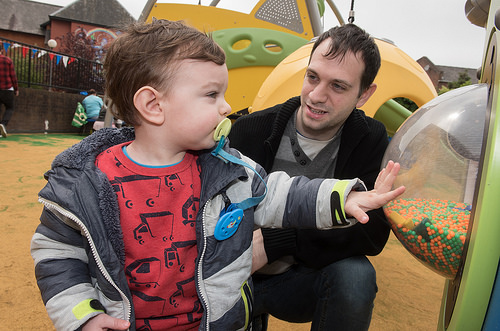<image>
Is the child to the left of the man? Yes. From this viewpoint, the child is positioned to the left side relative to the man. 